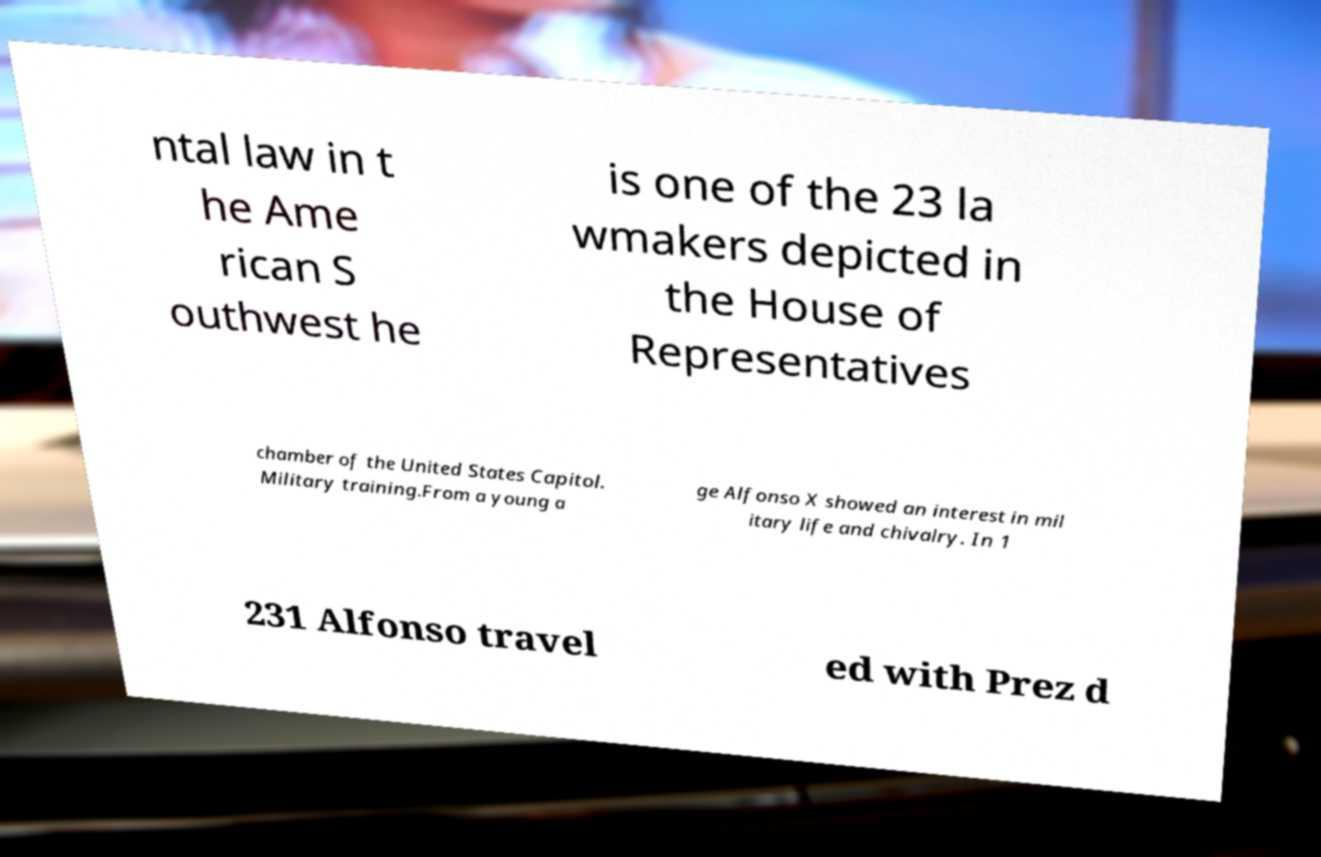Please read and relay the text visible in this image. What does it say? ntal law in t he Ame rican S outhwest he is one of the 23 la wmakers depicted in the House of Representatives chamber of the United States Capitol. Military training.From a young a ge Alfonso X showed an interest in mil itary life and chivalry. In 1 231 Alfonso travel ed with Prez d 